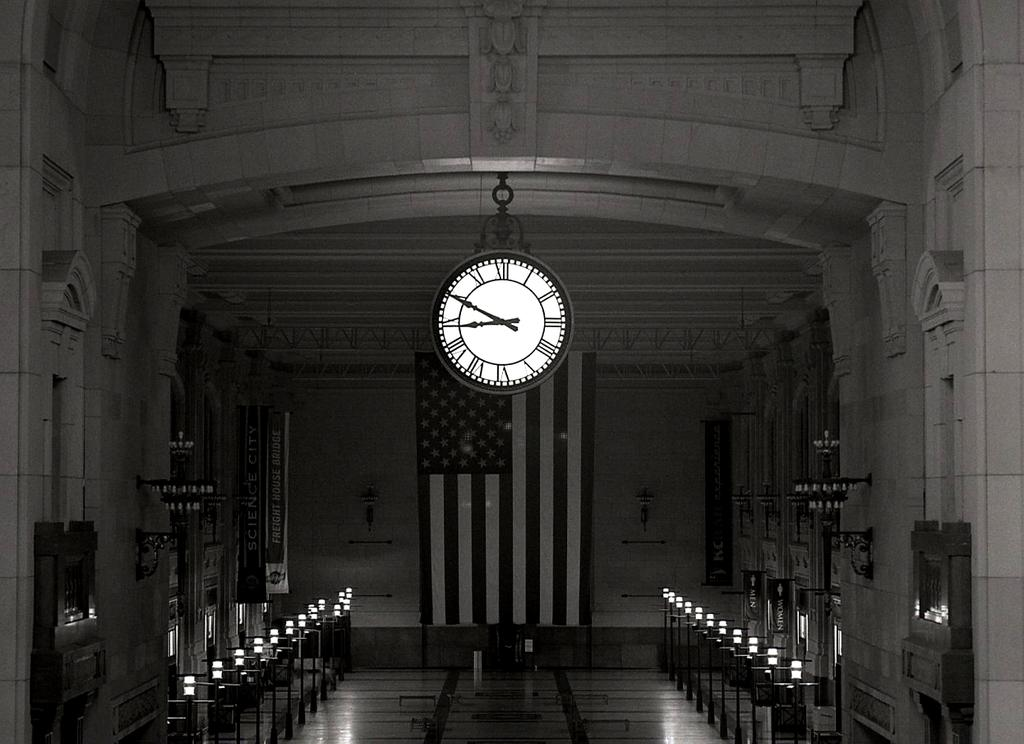<image>
Present a compact description of the photo's key features. A clock in front of the American flag points to the numbers 9 and 10 